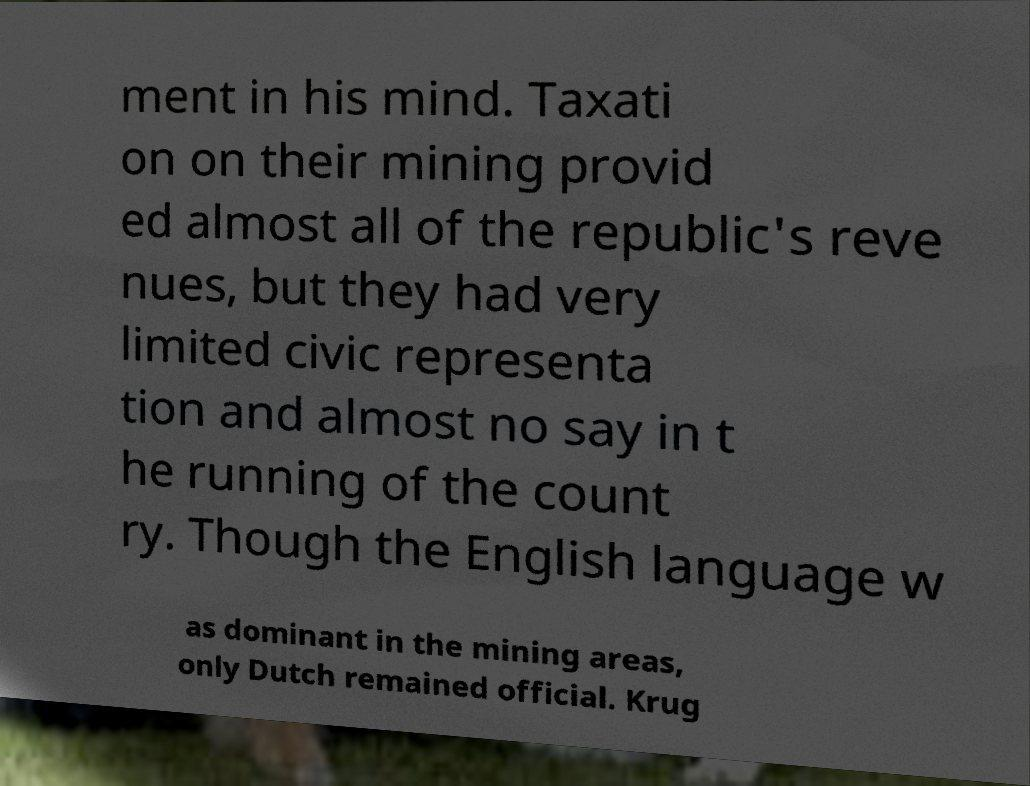I need the written content from this picture converted into text. Can you do that? ment in his mind. Taxati on on their mining provid ed almost all of the republic's reve nues, but they had very limited civic representa tion and almost no say in t he running of the count ry. Though the English language w as dominant in the mining areas, only Dutch remained official. Krug 